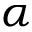Convert formula to latex. <formula><loc_0><loc_0><loc_500><loc_500>\alpha</formula> 